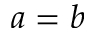<formula> <loc_0><loc_0><loc_500><loc_500>{ a = b }</formula> 